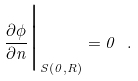<formula> <loc_0><loc_0><loc_500><loc_500>\frac { \partial \phi } { \partial n } \Big | _ { S ( 0 , R ) } = 0 \ .</formula> 